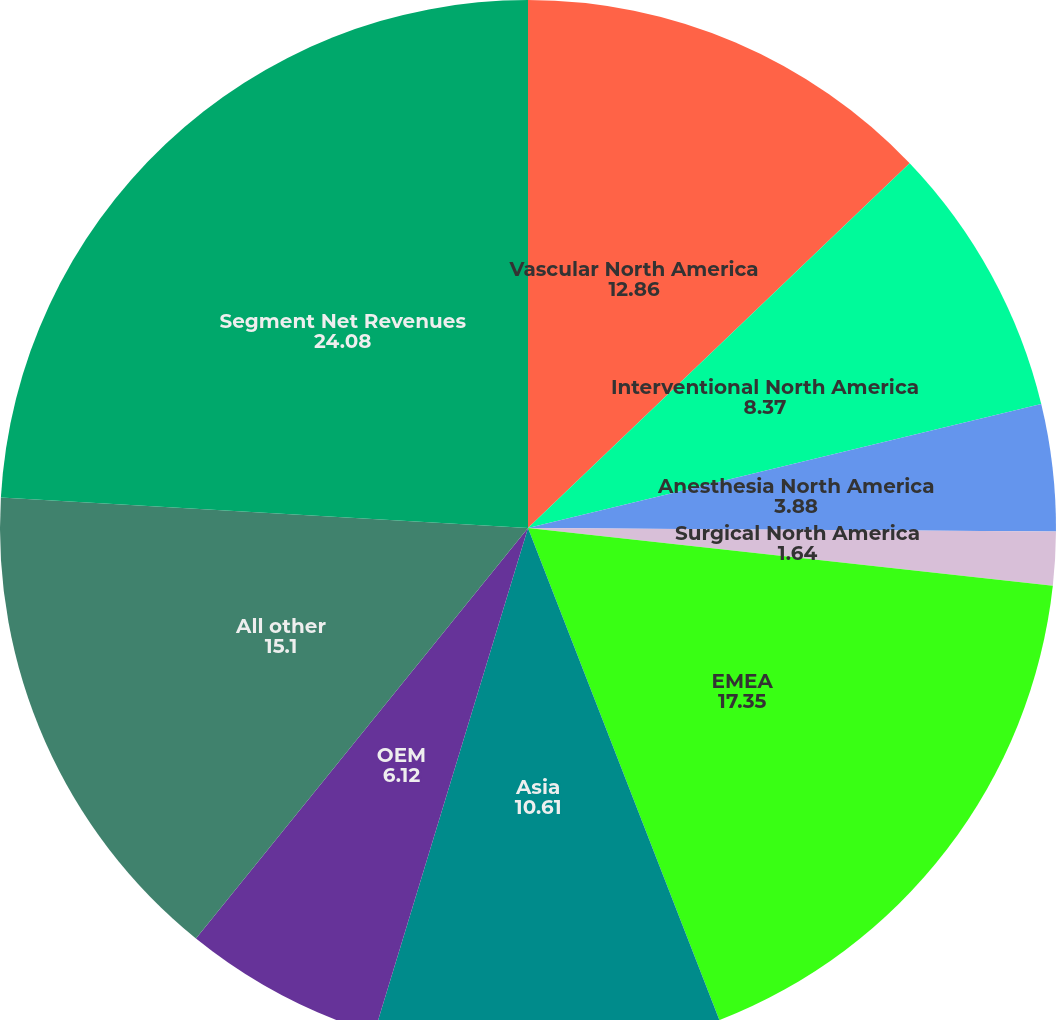Convert chart. <chart><loc_0><loc_0><loc_500><loc_500><pie_chart><fcel>Vascular North America<fcel>Interventional North America<fcel>Anesthesia North America<fcel>Surgical North America<fcel>EMEA<fcel>Asia<fcel>OEM<fcel>All other<fcel>Segment Net Revenues<nl><fcel>12.86%<fcel>8.37%<fcel>3.88%<fcel>1.64%<fcel>17.35%<fcel>10.61%<fcel>6.12%<fcel>15.1%<fcel>24.08%<nl></chart> 